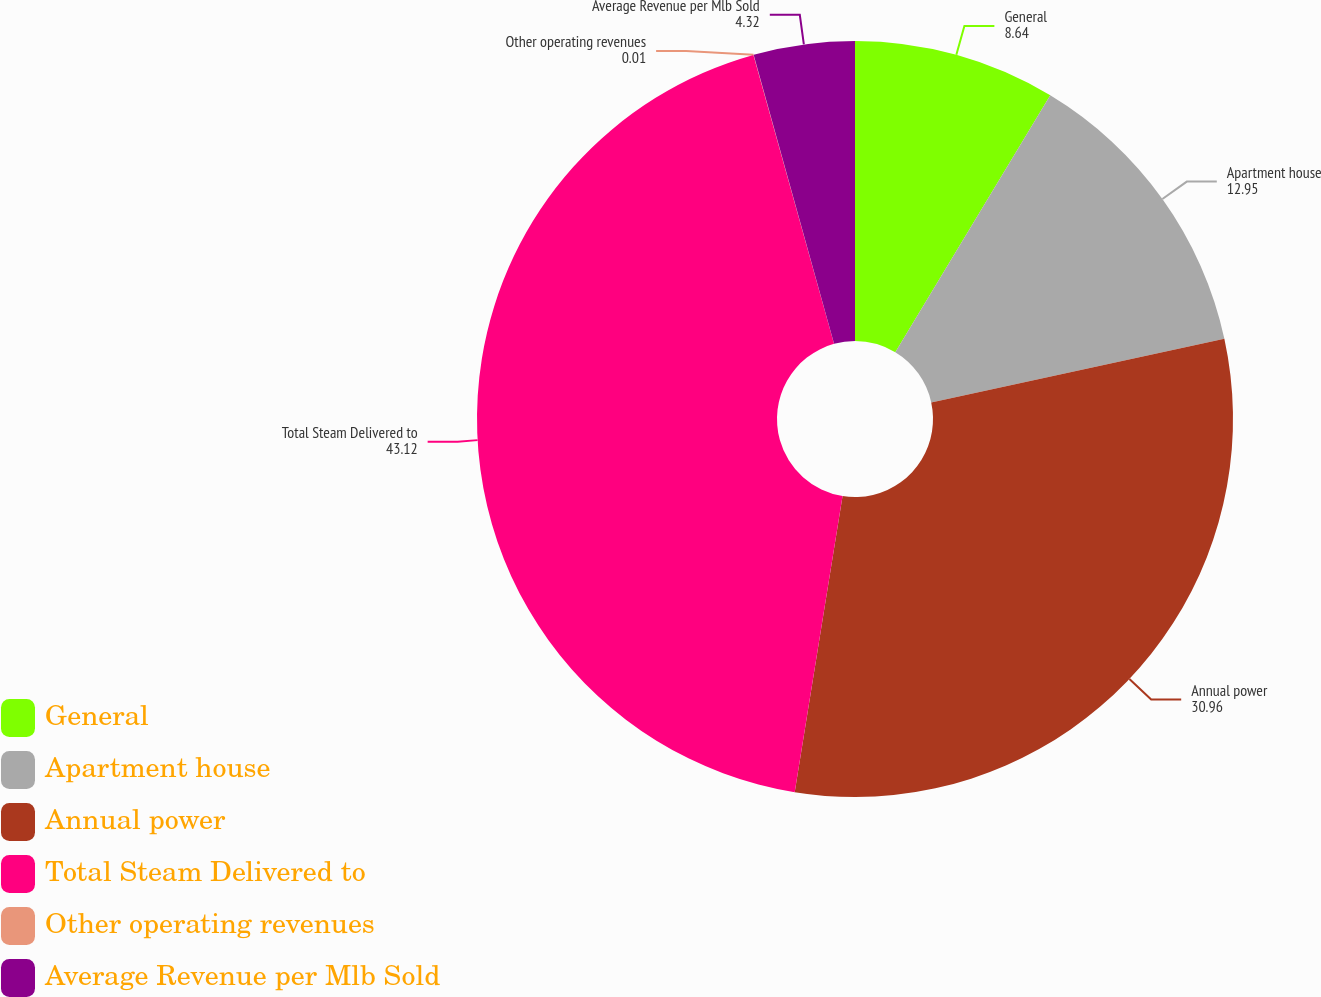<chart> <loc_0><loc_0><loc_500><loc_500><pie_chart><fcel>General<fcel>Apartment house<fcel>Annual power<fcel>Total Steam Delivered to<fcel>Other operating revenues<fcel>Average Revenue per Mlb Sold<nl><fcel>8.64%<fcel>12.95%<fcel>30.96%<fcel>43.12%<fcel>0.01%<fcel>4.32%<nl></chart> 